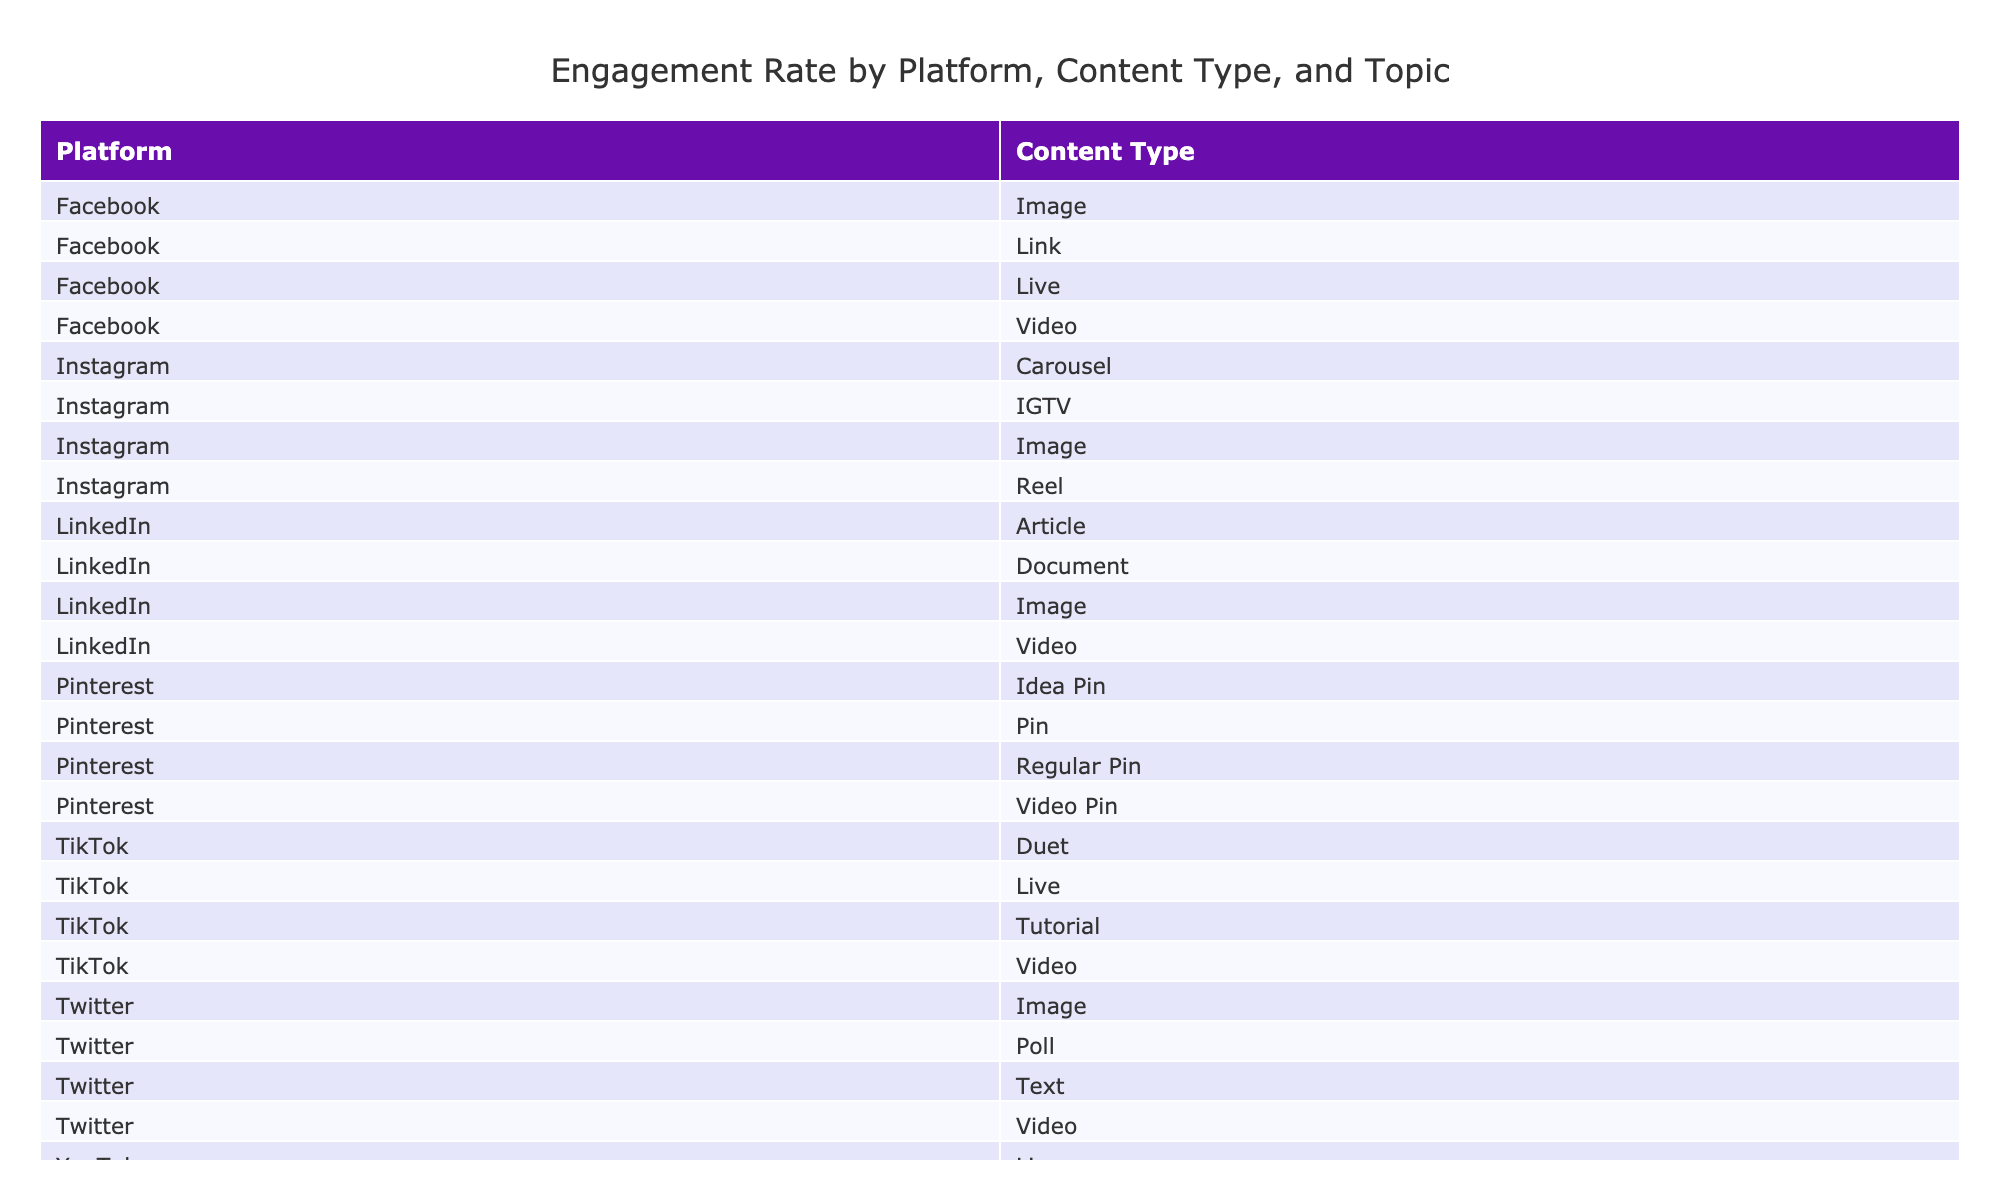What is the highest engagement rate for video content across all platforms? Looking through the table, locate the video content rows and identify the engagement rates. The highest engagement rate for video content is found in the YouTube regular content, which has an engagement rate of 8.9%.
Answer: 8.9% Which content type on TikTok has the largest number of likes? Review the likes column for all TikTok content types. The TikTok video titled "1-Minute Room Transformation" has the highest likes at 15,000.
Answer: 15,000 What is the average engagement rate for content related to decluttering tips across all platforms? First, identify all rows related to decluttering tips and take their engagement rates: Instagram (11.0%), YouTube Short (10.2%), and TikTok Live (11.2%). Then, add these rates: 11.0 + 10.2 + 11.2 = 32.4. Finally, divide by the number of entries, which is 3: 32.4 / 3 = 10.8%.
Answer: 10.8% Does Facebook have any content types with engagement rates exceeding 11%? Review the engagement rates for all Facebook content types. The Q&A session has an engagement rate of 11.2%, which confirms that yes, Facebook has content exceeding an 11% engagement rate.
Answer: Yes What is the total number of shares for Pinterest content types? Collect data from the shares column for Pinterest content types: 1800 (Closet Organization Ideas) + 1300 (15-Minute Productivity Routine) + 2200 (Minimalist Kitchen Tour) + 1500 (Home Office Storage Solutions) equals 7800 shares in total.
Answer: 7800 Which platform had the lowest engagement rate overall, and what was that rate? Look at the engagement rates for all platforms and identify the minimum. The Facebook video, "Weekly Meal Prep Guide," has the lowest engagement rate at 8.5%.
Answer: 8.5% Which content type on Instagram received the most views? Check the views column for all Instagram content types. The Instagram Reel titled "Minimalist Home Tour" received the most views, at 45,000.
Answer: 45,000 What is the difference in engagement rates between the highest and lowest TikTok content types? Review the engagement rates for TikTok content: 10.4% (1-Minute Room Transformation), 10.0% (Productivity Hack Challenge), 11.2% (Decluttering Tips Q&A), and 10.5% (Bullet Journaling for Beginners). The highest rate is 11.2%, and the lowest is 10.0%. The difference is 11.2% - 10.0% = 1.2%.
Answer: 1.2% 